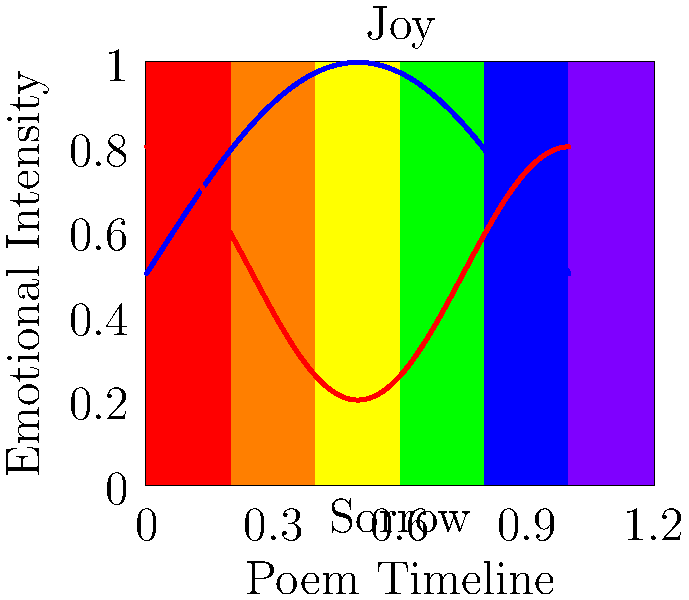In the color spectrum graph above, two emotional arcs are depicted for a poem: one in blue and one in red. Considering the color spectrum as a representation of emotional states (with warm colors indicating positive emotions and cool colors indicating negative emotions), how would you interpret the overall emotional journey of the poem, and which arc seems to end on a more hopeful note? To interpret the emotional impact of the poem using the color spectrum graph, we need to follow these steps:

1. Understand the color spectrum:
   - Warm colors (red, orange, yellow) represent positive emotions
   - Cool colors (green, blue, purple) represent negative emotions

2. Analyze the blue arc:
   - Starts in the middle of the spectrum (neutral)
   - Rises towards warm colors (positive emotions)
   - Ends slightly above the starting point in the yellow-green range

3. Analyze the red arc:
   - Starts in the middle of the spectrum (neutral)
   - Dips towards cool colors (negative emotions)
   - Ends slightly below the starting point in the yellow-orange range

4. Compare the overall journeys:
   - Blue arc has a more pronounced positive peak
   - Red arc has a more pronounced negative dip
   - Both arcs end close to where they started, but in slightly different emotional states

5. Determine which arc ends on a more hopeful note:
   - The red arc ends slightly higher in the warm color range compared to the blue arc
   - This suggests that the red arc concludes with a more positive emotion

Considering these factors, we can interpret that the poem likely explores both positive and negative emotional states, with moments of joy and sorrow. The overall journey seems to be one of emotional fluctuation, possibly reflecting on life's ups and downs. The red arc, despite having a lower emotional point during the poem, ends on a slightly more hopeful note in the warmer color spectrum.
Answer: The poem explores emotional fluctuations, and the red arc ends on a more hopeful note. 